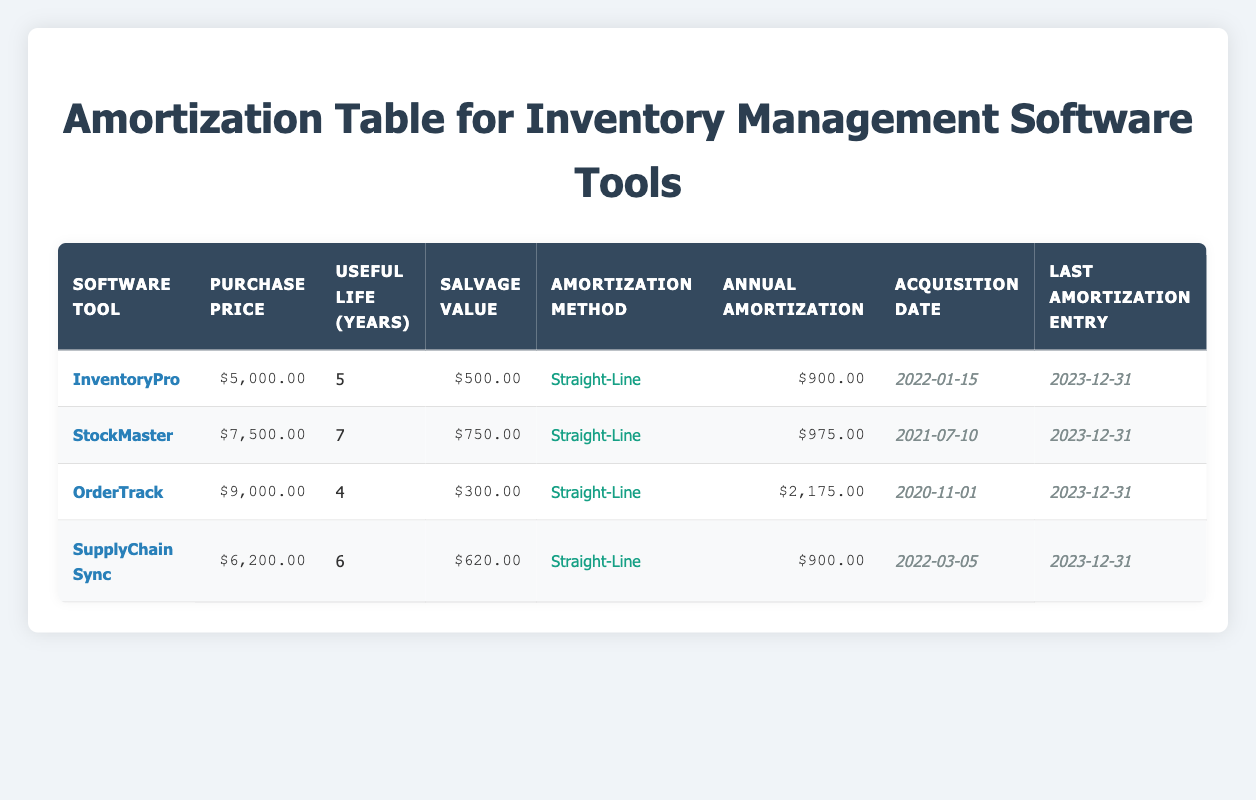What is the purchase price of the software tool "OrderTrack"? The purchase price of "OrderTrack" can be found in the corresponding row in the table under the "Purchase Price" column. It is listed as $9,000.00.
Answer: $9,000.00 What is the annual amortization amount for "StockMaster"? The annual amortization amount for "StockMaster" is found in the "Annual Amortization" column for that specific software tool. It is listed as $975.00.
Answer: $975.00 Which software tool has the longest useful life? To determine which software tool has the longest useful life, we need to compare the "Useful Life (Years)" column across all software tools. "StockMaster" has the highest value at 7 years.
Answer: StockMaster What is the total annual amortization for all software tools combined? To find the total annual amortization, we sum the annual amortization values for each software tool: $900.00 (InventoryPro) + $975.00 (StockMaster) + $2,175.00 (OrderTrack) + $900.00 (SupplyChain Sync) = $4,950.00.
Answer: $4,950.00 Is the salvage value of "SupplyChain Sync" more than $500? The salvage value for "SupplyChain Sync" is listed as $620.00 in the table. Since $620.00 is greater than $500, the statement is true.
Answer: Yes What is the average useful life of all software tools in years? We sum the useful life values: 5 (InventoryPro) + 7 (StockMaster) + 4 (OrderTrack) + 6 (SupplyChain Sync) = 22 years. We then divide this sum by the total number of software tools (4) to get the average: 22 / 4 = 5.5 years.
Answer: 5.5 years Which software tool has the highest annual amortization? To find the software tool with the highest annual amortization, we look at the "Annual Amortization" column. "OrderTrack" has the highest amount listed at $2,175.00.
Answer: OrderTrack Does "InventoryPro" have a higher acquisition date than "SupplyChain Sync"? The acquisition date for "InventoryPro" is January 15, 2022, while for "SupplyChain Sync" is March 5, 2022. Since January 15 is earlier than March 5, the answer is false.
Answer: No If all software tools were to be disposed of on the same day, what would be the total salvage value? The total salvage value is found by summing the salvage values from each software tool: $500.00 (InventoryPro) + $750.00 (StockMaster) + $300.00 (OrderTrack) + $620.00 (SupplyChain Sync) = $2,170.00.
Answer: $2,170.00 